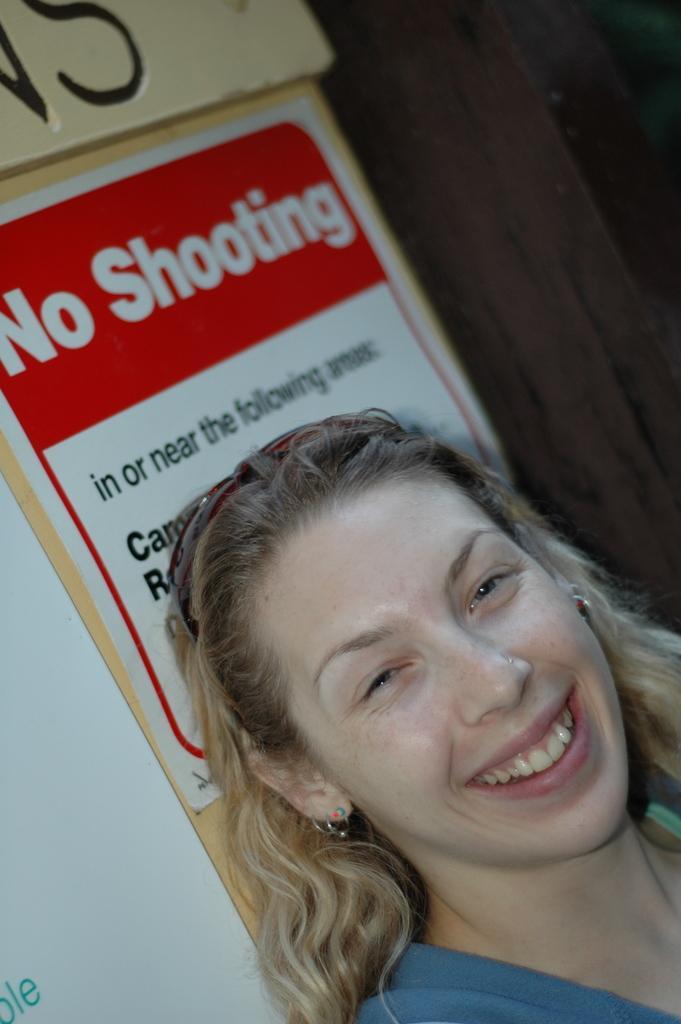Describe this image in one or two sentences. In the center of the image we can see a lady is smiling and wearing a dress, goggles. In the background of the image we can see the wall and boards. On the boards we can see the text. 